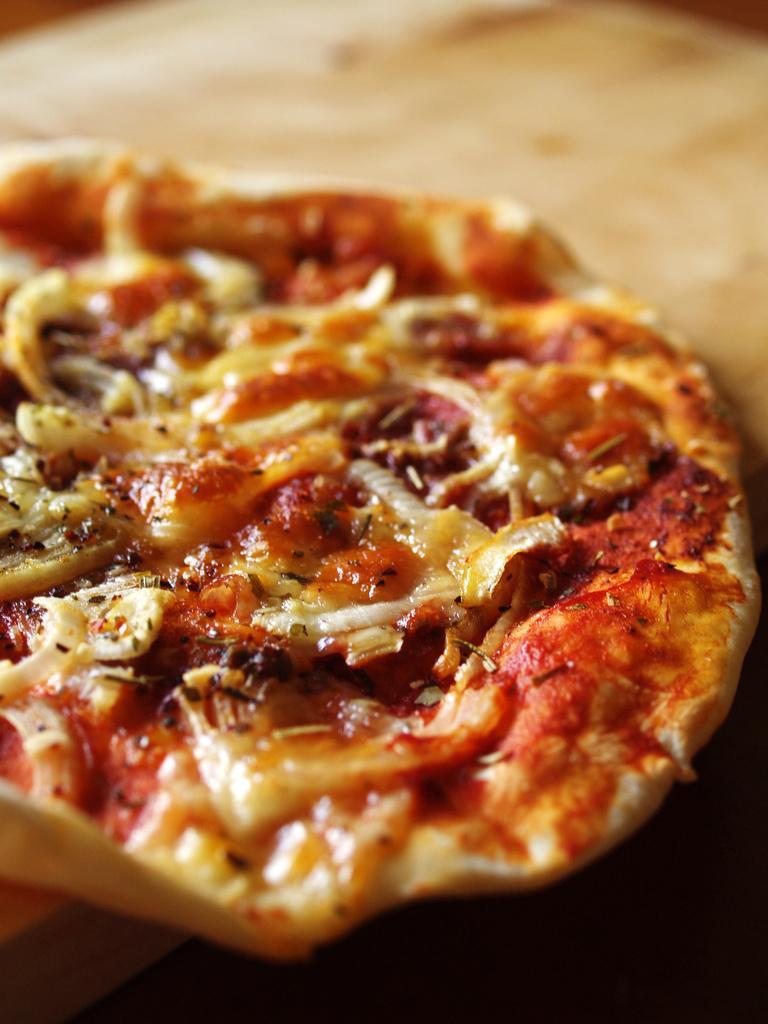Can you describe this image briefly? In this image we can see a food item on the surface. 